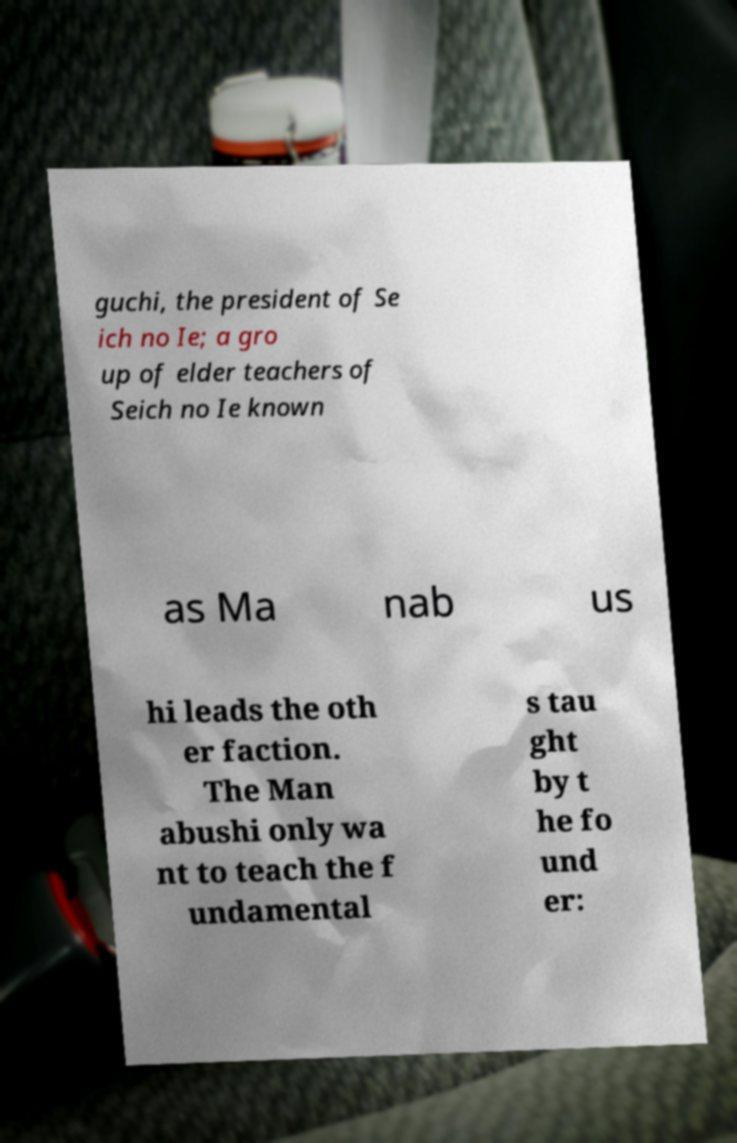Can you read and provide the text displayed in the image?This photo seems to have some interesting text. Can you extract and type it out for me? guchi, the president of Se ich no Ie; a gro up of elder teachers of Seich no Ie known as Ma nab us hi leads the oth er faction. The Man abushi only wa nt to teach the f undamental s tau ght by t he fo und er: 